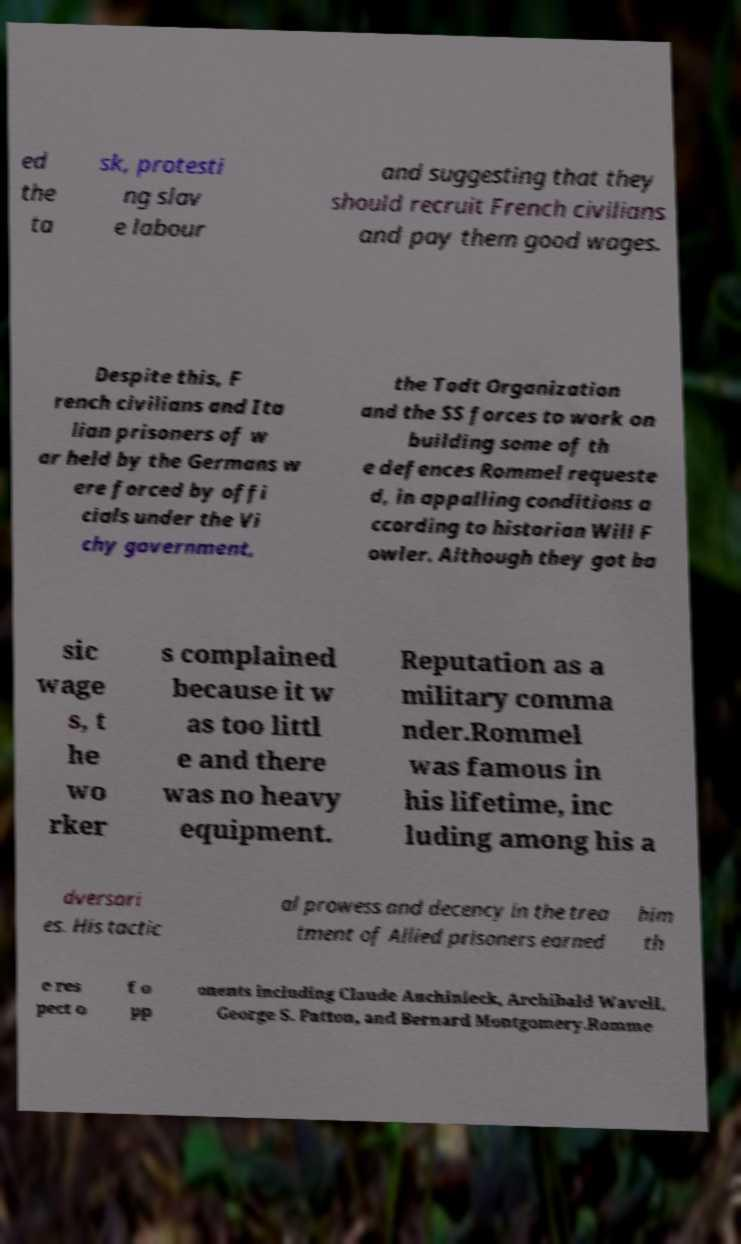Please read and relay the text visible in this image. What does it say? ed the ta sk, protesti ng slav e labour and suggesting that they should recruit French civilians and pay them good wages. Despite this, F rench civilians and Ita lian prisoners of w ar held by the Germans w ere forced by offi cials under the Vi chy government, the Todt Organization and the SS forces to work on building some of th e defences Rommel requeste d, in appalling conditions a ccording to historian Will F owler. Although they got ba sic wage s, t he wo rker s complained because it w as too littl e and there was no heavy equipment. Reputation as a military comma nder.Rommel was famous in his lifetime, inc luding among his a dversari es. His tactic al prowess and decency in the trea tment of Allied prisoners earned him th e res pect o f o pp onents including Claude Auchinleck, Archibald Wavell, George S. Patton, and Bernard Montgomery.Romme 